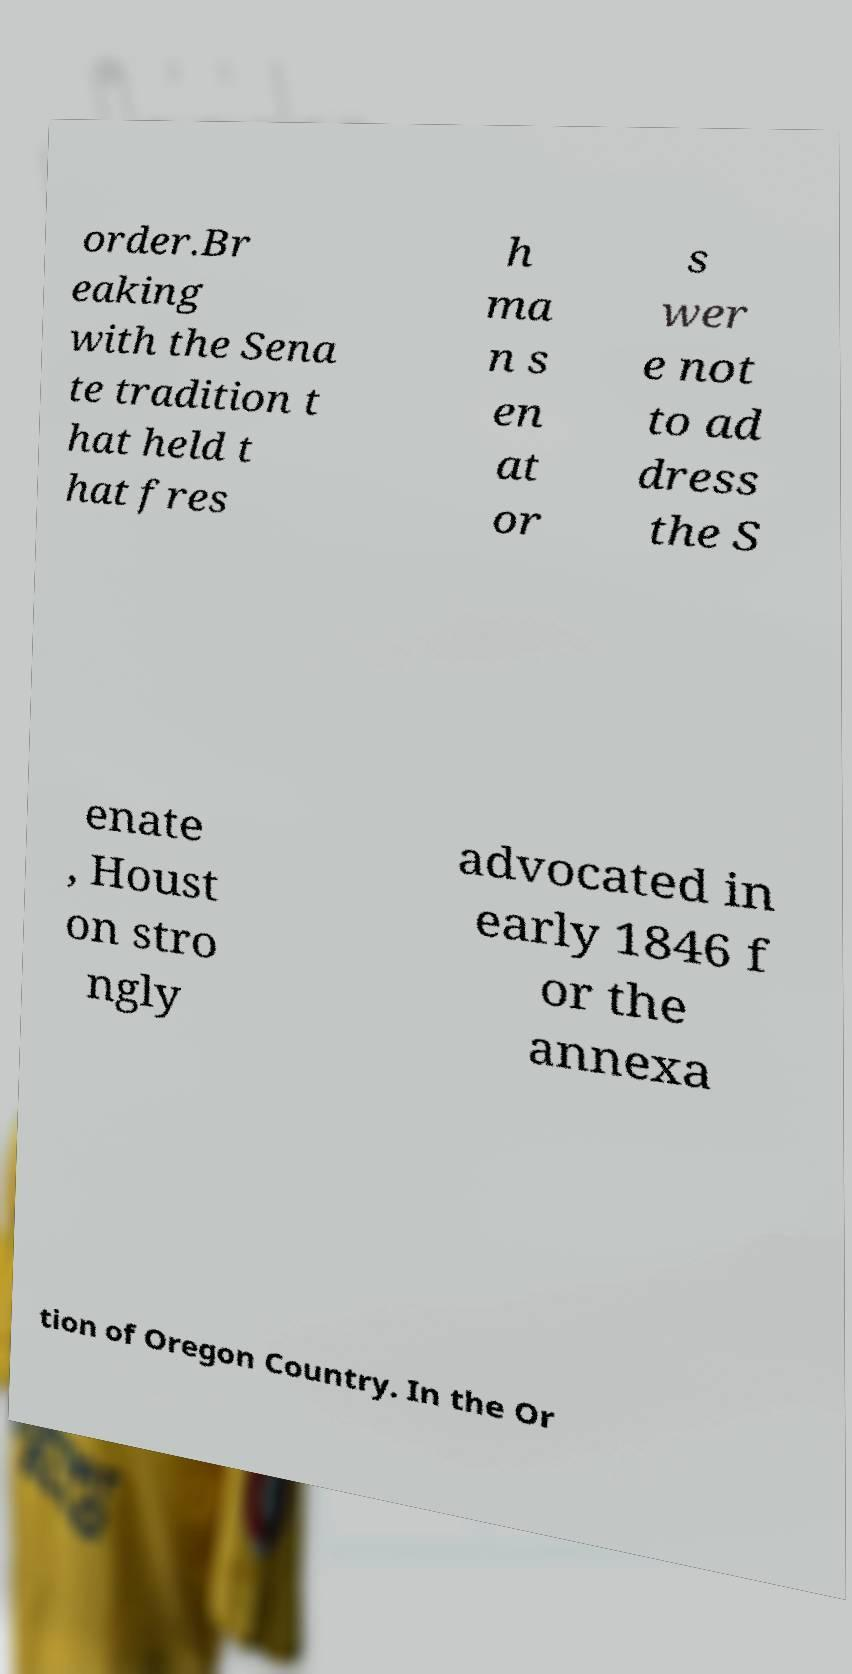Can you read and provide the text displayed in the image?This photo seems to have some interesting text. Can you extract and type it out for me? order.Br eaking with the Sena te tradition t hat held t hat fres h ma n s en at or s wer e not to ad dress the S enate , Houst on stro ngly advocated in early 1846 f or the annexa tion of Oregon Country. In the Or 